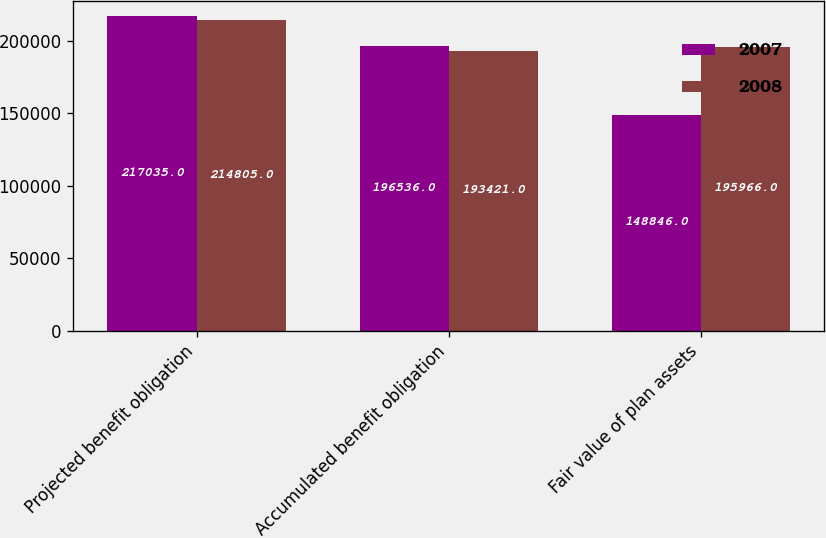Convert chart to OTSL. <chart><loc_0><loc_0><loc_500><loc_500><stacked_bar_chart><ecel><fcel>Projected benefit obligation<fcel>Accumulated benefit obligation<fcel>Fair value of plan assets<nl><fcel>2007<fcel>217035<fcel>196536<fcel>148846<nl><fcel>2008<fcel>214805<fcel>193421<fcel>195966<nl></chart> 